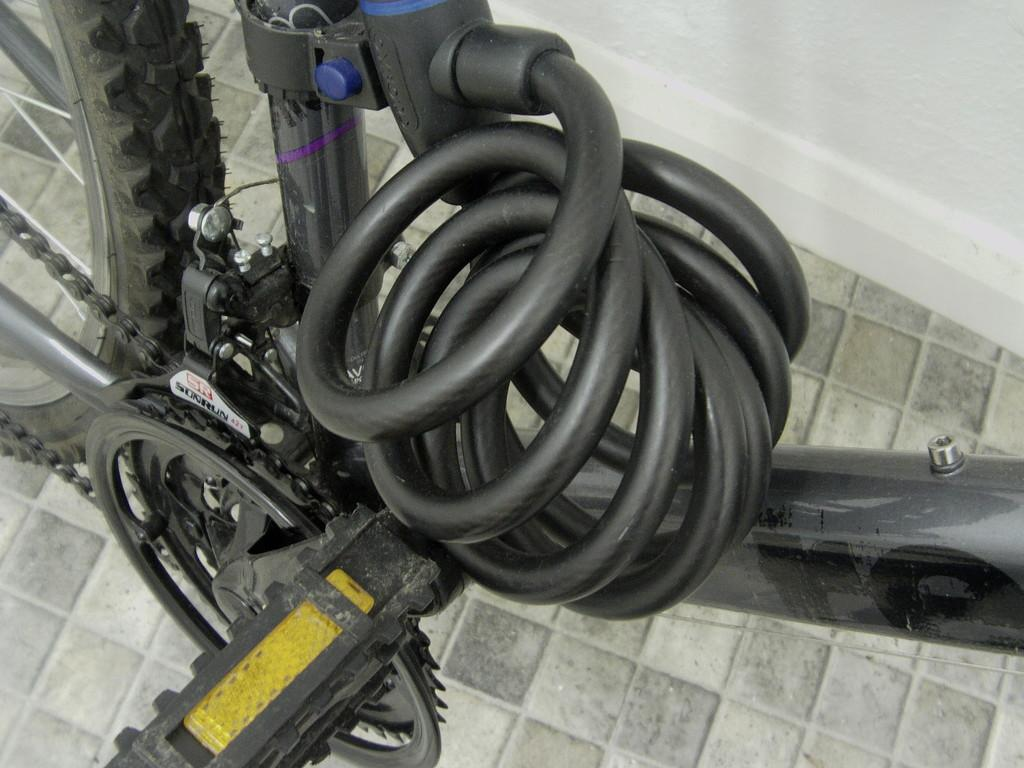What is the main mode of transportation in the image? There is a cycle in the image. What piece of furniture is located on the left side of the image? There is a chair on the left side of the image. Can you describe the object in the top left corner of the image? There is a tier in the top left corner of the image. What type of love can be seen in the image? There is no love present in the image; it features a cycle, a chair, and a tier. Is there a camp visible in the image? There is no camp present in the image. 